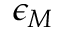<formula> <loc_0><loc_0><loc_500><loc_500>\epsilon _ { M }</formula> 